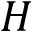Convert formula to latex. <formula><loc_0><loc_0><loc_500><loc_500>H</formula> 